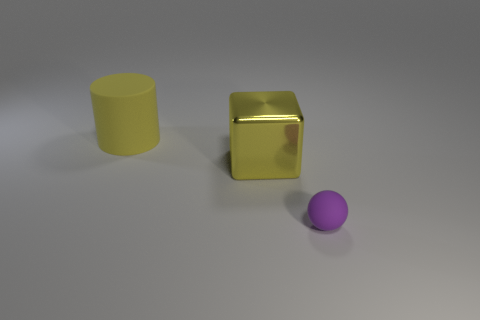Subtract all blue blocks. Subtract all cyan balls. How many blocks are left? 1 Add 2 blocks. How many objects exist? 5 Subtract all balls. How many objects are left? 2 Add 2 yellow metallic things. How many yellow metallic things are left? 3 Add 1 blocks. How many blocks exist? 2 Subtract 0 brown cylinders. How many objects are left? 3 Subtract all purple metal cubes. Subtract all purple balls. How many objects are left? 2 